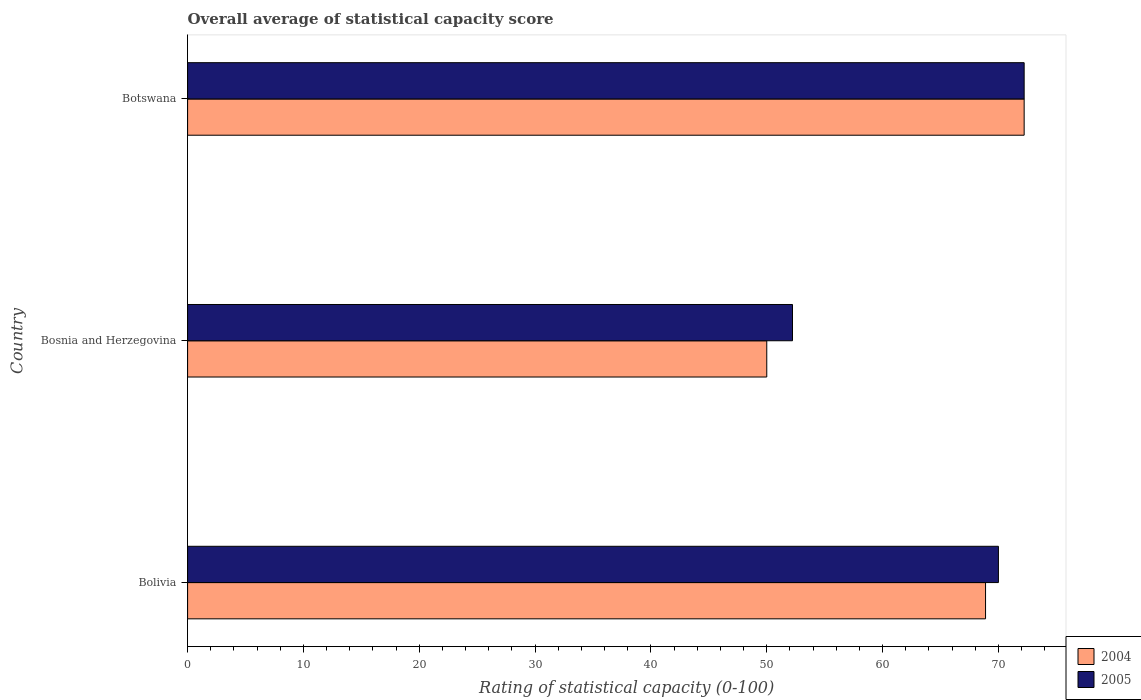How many different coloured bars are there?
Your answer should be very brief. 2. Are the number of bars per tick equal to the number of legend labels?
Keep it short and to the point. Yes. How many bars are there on the 2nd tick from the bottom?
Provide a succinct answer. 2. What is the label of the 2nd group of bars from the top?
Your answer should be compact. Bosnia and Herzegovina. In how many cases, is the number of bars for a given country not equal to the number of legend labels?
Your answer should be very brief. 0. What is the rating of statistical capacity in 2005 in Bosnia and Herzegovina?
Your answer should be compact. 52.22. Across all countries, what is the maximum rating of statistical capacity in 2004?
Your response must be concise. 72.22. Across all countries, what is the minimum rating of statistical capacity in 2004?
Provide a short and direct response. 50. In which country was the rating of statistical capacity in 2004 maximum?
Keep it short and to the point. Botswana. In which country was the rating of statistical capacity in 2004 minimum?
Provide a short and direct response. Bosnia and Herzegovina. What is the total rating of statistical capacity in 2004 in the graph?
Make the answer very short. 191.11. What is the difference between the rating of statistical capacity in 2004 in Bosnia and Herzegovina and that in Botswana?
Your answer should be compact. -22.22. What is the difference between the rating of statistical capacity in 2004 in Bolivia and the rating of statistical capacity in 2005 in Bosnia and Herzegovina?
Ensure brevity in your answer.  16.67. What is the average rating of statistical capacity in 2005 per country?
Give a very brief answer. 64.81. What is the difference between the rating of statistical capacity in 2005 and rating of statistical capacity in 2004 in Bosnia and Herzegovina?
Keep it short and to the point. 2.22. In how many countries, is the rating of statistical capacity in 2005 greater than 8 ?
Ensure brevity in your answer.  3. What is the ratio of the rating of statistical capacity in 2005 in Bolivia to that in Botswana?
Your response must be concise. 0.97. Is the rating of statistical capacity in 2004 in Bolivia less than that in Bosnia and Herzegovina?
Your answer should be compact. No. Is the difference between the rating of statistical capacity in 2005 in Bosnia and Herzegovina and Botswana greater than the difference between the rating of statistical capacity in 2004 in Bosnia and Herzegovina and Botswana?
Ensure brevity in your answer.  Yes. What is the difference between the highest and the second highest rating of statistical capacity in 2004?
Your response must be concise. 3.33. What is the difference between the highest and the lowest rating of statistical capacity in 2004?
Keep it short and to the point. 22.22. In how many countries, is the rating of statistical capacity in 2005 greater than the average rating of statistical capacity in 2005 taken over all countries?
Make the answer very short. 2. What does the 1st bar from the top in Botswana represents?
Keep it short and to the point. 2005. How many bars are there?
Offer a terse response. 6. Are all the bars in the graph horizontal?
Your answer should be compact. Yes. How many countries are there in the graph?
Make the answer very short. 3. What is the difference between two consecutive major ticks on the X-axis?
Your answer should be compact. 10. Are the values on the major ticks of X-axis written in scientific E-notation?
Keep it short and to the point. No. Does the graph contain any zero values?
Make the answer very short. No. Where does the legend appear in the graph?
Offer a terse response. Bottom right. How many legend labels are there?
Provide a short and direct response. 2. How are the legend labels stacked?
Keep it short and to the point. Vertical. What is the title of the graph?
Offer a terse response. Overall average of statistical capacity score. What is the label or title of the X-axis?
Offer a very short reply. Rating of statistical capacity (0-100). What is the label or title of the Y-axis?
Keep it short and to the point. Country. What is the Rating of statistical capacity (0-100) of 2004 in Bolivia?
Give a very brief answer. 68.89. What is the Rating of statistical capacity (0-100) of 2004 in Bosnia and Herzegovina?
Keep it short and to the point. 50. What is the Rating of statistical capacity (0-100) of 2005 in Bosnia and Herzegovina?
Ensure brevity in your answer.  52.22. What is the Rating of statistical capacity (0-100) of 2004 in Botswana?
Keep it short and to the point. 72.22. What is the Rating of statistical capacity (0-100) of 2005 in Botswana?
Your answer should be very brief. 72.22. Across all countries, what is the maximum Rating of statistical capacity (0-100) in 2004?
Make the answer very short. 72.22. Across all countries, what is the maximum Rating of statistical capacity (0-100) in 2005?
Provide a succinct answer. 72.22. Across all countries, what is the minimum Rating of statistical capacity (0-100) in 2004?
Offer a very short reply. 50. Across all countries, what is the minimum Rating of statistical capacity (0-100) in 2005?
Provide a succinct answer. 52.22. What is the total Rating of statistical capacity (0-100) of 2004 in the graph?
Provide a succinct answer. 191.11. What is the total Rating of statistical capacity (0-100) of 2005 in the graph?
Your response must be concise. 194.44. What is the difference between the Rating of statistical capacity (0-100) of 2004 in Bolivia and that in Bosnia and Herzegovina?
Offer a very short reply. 18.89. What is the difference between the Rating of statistical capacity (0-100) of 2005 in Bolivia and that in Bosnia and Herzegovina?
Ensure brevity in your answer.  17.78. What is the difference between the Rating of statistical capacity (0-100) of 2005 in Bolivia and that in Botswana?
Offer a very short reply. -2.22. What is the difference between the Rating of statistical capacity (0-100) of 2004 in Bosnia and Herzegovina and that in Botswana?
Provide a succinct answer. -22.22. What is the difference between the Rating of statistical capacity (0-100) in 2005 in Bosnia and Herzegovina and that in Botswana?
Keep it short and to the point. -20. What is the difference between the Rating of statistical capacity (0-100) in 2004 in Bolivia and the Rating of statistical capacity (0-100) in 2005 in Bosnia and Herzegovina?
Make the answer very short. 16.67. What is the difference between the Rating of statistical capacity (0-100) in 2004 in Bolivia and the Rating of statistical capacity (0-100) in 2005 in Botswana?
Ensure brevity in your answer.  -3.33. What is the difference between the Rating of statistical capacity (0-100) of 2004 in Bosnia and Herzegovina and the Rating of statistical capacity (0-100) of 2005 in Botswana?
Provide a short and direct response. -22.22. What is the average Rating of statistical capacity (0-100) of 2004 per country?
Make the answer very short. 63.7. What is the average Rating of statistical capacity (0-100) of 2005 per country?
Keep it short and to the point. 64.81. What is the difference between the Rating of statistical capacity (0-100) of 2004 and Rating of statistical capacity (0-100) of 2005 in Bolivia?
Your answer should be very brief. -1.11. What is the difference between the Rating of statistical capacity (0-100) in 2004 and Rating of statistical capacity (0-100) in 2005 in Bosnia and Herzegovina?
Offer a terse response. -2.22. What is the ratio of the Rating of statistical capacity (0-100) in 2004 in Bolivia to that in Bosnia and Herzegovina?
Make the answer very short. 1.38. What is the ratio of the Rating of statistical capacity (0-100) of 2005 in Bolivia to that in Bosnia and Herzegovina?
Keep it short and to the point. 1.34. What is the ratio of the Rating of statistical capacity (0-100) in 2004 in Bolivia to that in Botswana?
Provide a short and direct response. 0.95. What is the ratio of the Rating of statistical capacity (0-100) of 2005 in Bolivia to that in Botswana?
Ensure brevity in your answer.  0.97. What is the ratio of the Rating of statistical capacity (0-100) of 2004 in Bosnia and Herzegovina to that in Botswana?
Provide a short and direct response. 0.69. What is the ratio of the Rating of statistical capacity (0-100) in 2005 in Bosnia and Herzegovina to that in Botswana?
Keep it short and to the point. 0.72. What is the difference between the highest and the second highest Rating of statistical capacity (0-100) of 2004?
Keep it short and to the point. 3.33. What is the difference between the highest and the second highest Rating of statistical capacity (0-100) of 2005?
Ensure brevity in your answer.  2.22. What is the difference between the highest and the lowest Rating of statistical capacity (0-100) in 2004?
Make the answer very short. 22.22. 